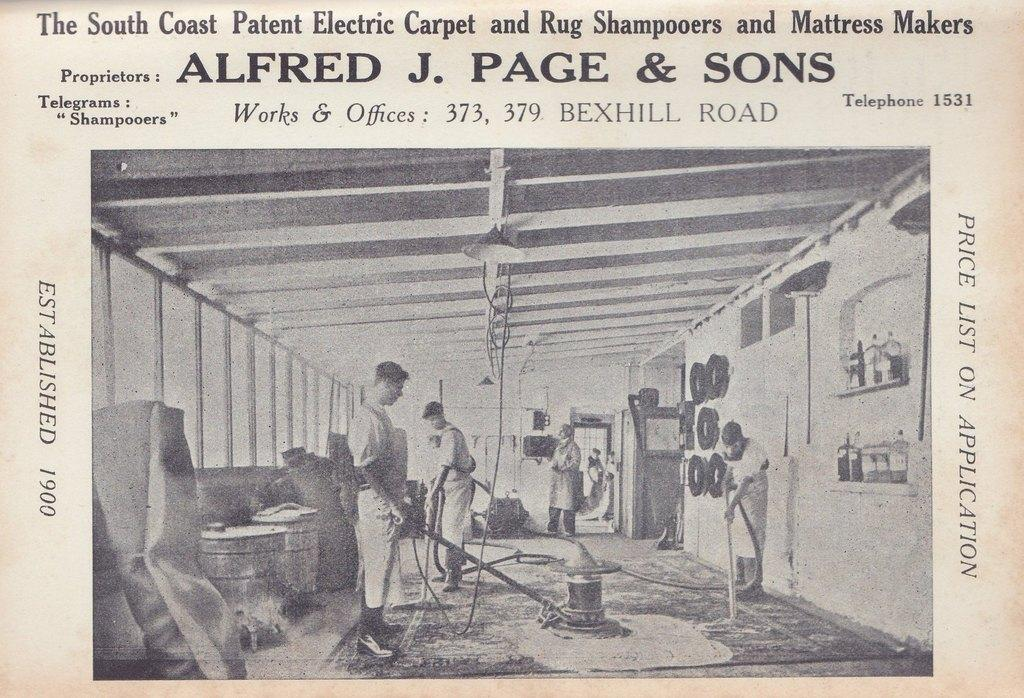What type of visual representation is shown in the image? The image is a poster. What can be seen happening in the poster? There are people standing on the floor in the poster. What musical instruments are present in the poster? There are drums in the poster. Are there any other objects or elements in the poster besides the people and drums? Yes, there are other objects present in the poster. How many pigs are playing with the toys in the poster? There are no pigs or toys present in the poster; it features people and drums. 